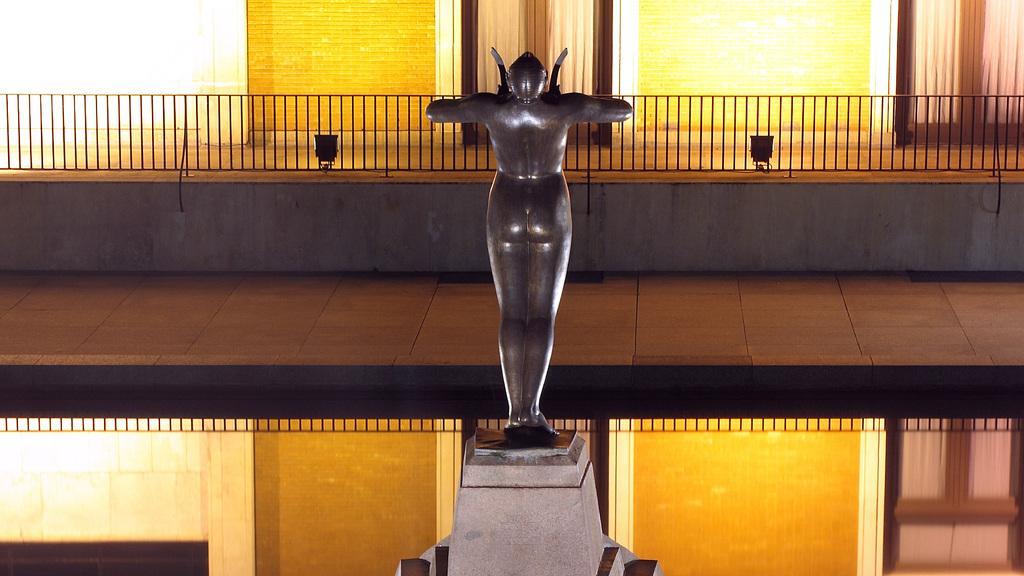Please provide a concise description of this image. This picture shows a building and a statue and we see couple of lights and blinds to the windows. 